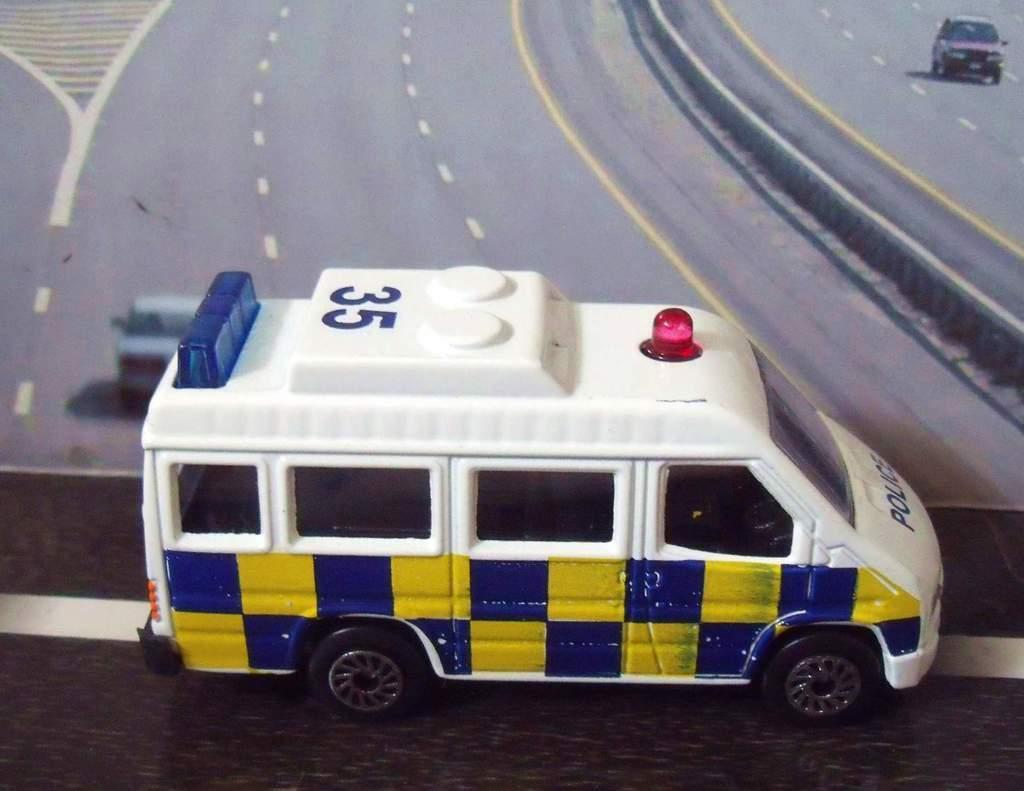Can you describe this image briefly? In this image we can see a toy placed on the surface. In the background, we can see a picture in which we can see some vehicles parked on the ground and a crash barrier. 